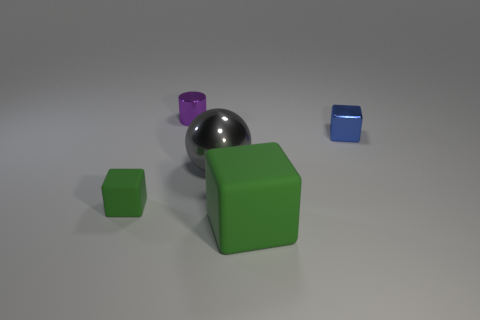Subtract all brown cubes. Subtract all green balls. How many cubes are left? 3 Add 5 small brown shiny cylinders. How many objects exist? 10 Subtract all cylinders. How many objects are left? 4 Add 4 tiny green blocks. How many tiny green blocks are left? 5 Add 5 blue metallic objects. How many blue metallic objects exist? 6 Subtract 1 blue cubes. How many objects are left? 4 Subtract all large gray metal things. Subtract all small blue things. How many objects are left? 3 